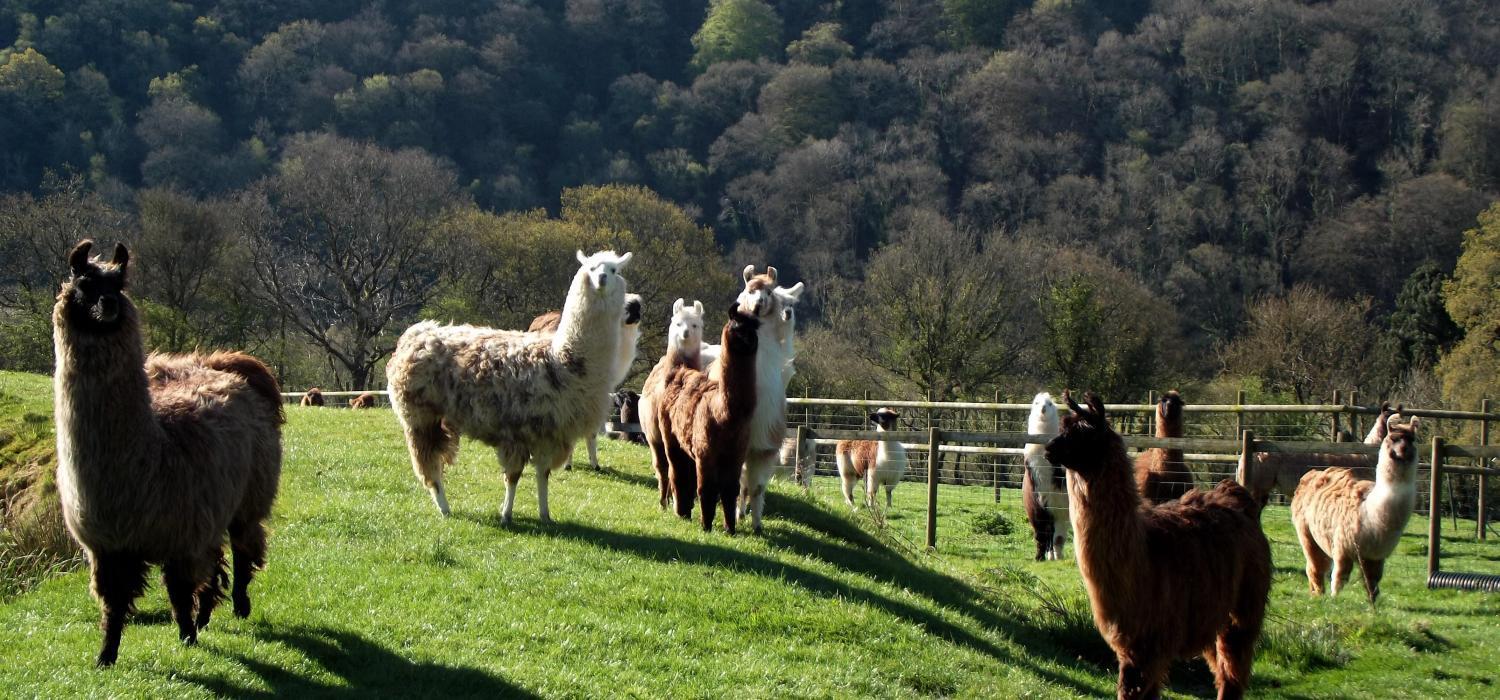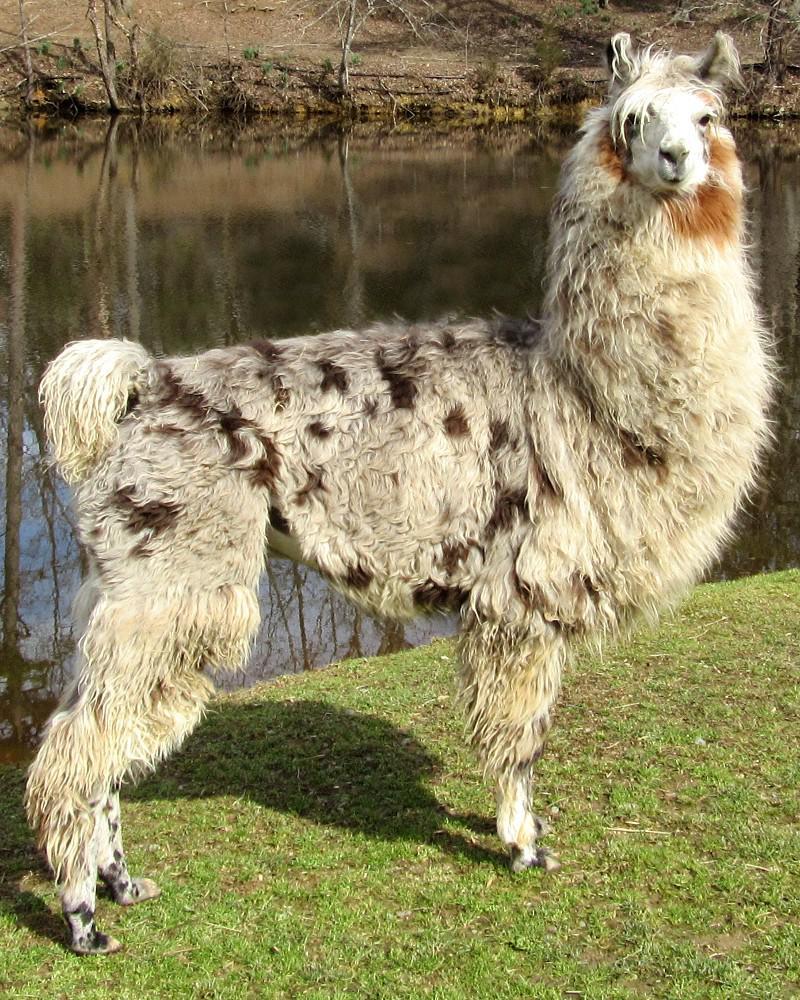The first image is the image on the left, the second image is the image on the right. Examine the images to the left and right. Is the description "One image shows a close-together group of several llamas with bodies turned forward, and the other image includes a person standing to the right of and looking at a llama while holding a rope attached to it." accurate? Answer yes or no. No. The first image is the image on the left, the second image is the image on the right. Examine the images to the left and right. Is the description "At least one person is standing outside with the animals in one of the images." accurate? Answer yes or no. No. 